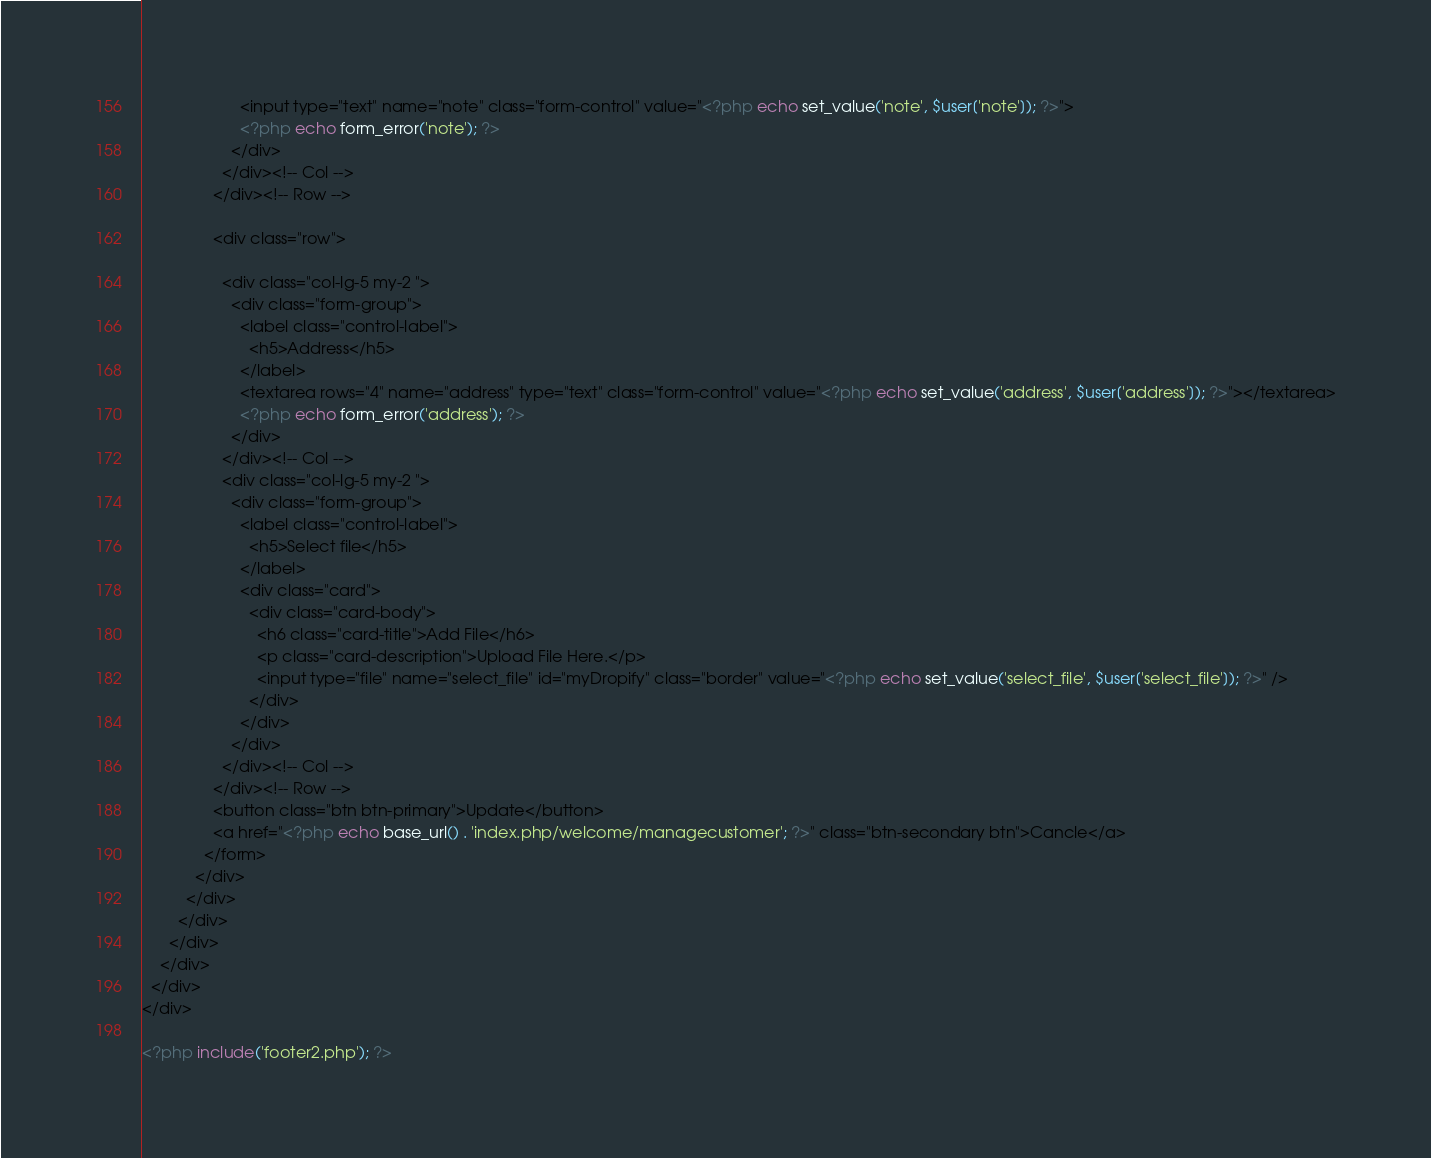<code> <loc_0><loc_0><loc_500><loc_500><_PHP_>                      <input type="text" name="note" class="form-control" value="<?php echo set_value('note', $user['note']); ?>">
                      <?php echo form_error('note'); ?>
                    </div>
                  </div><!-- Col -->
                </div><!-- Row -->

                <div class="row">

                  <div class="col-lg-5 my-2 ">
                    <div class="form-group">
                      <label class="control-label">
                        <h5>Address</h5>
                      </label>
                      <textarea rows="4" name="address" type="text" class="form-control" value="<?php echo set_value('address', $user['address']); ?>"></textarea>
                      <?php echo form_error('address'); ?>
                    </div>
                  </div><!-- Col -->
                  <div class="col-lg-5 my-2 ">
                    <div class="form-group">
                      <label class="control-label">
                        <h5>Select file</h5>
                      </label>
                      <div class="card">
                        <div class="card-body">
                          <h6 class="card-title">Add File</h6>
                          <p class="card-description">Upload File Here.</p>
                          <input type="file" name="select_file" id="myDropify" class="border" value="<?php echo set_value('select_file', $user['select_file']); ?>" />
                        </div>
                      </div>
                    </div>
                  </div><!-- Col -->
                </div><!-- Row -->
                <button class="btn btn-primary">Update</button>
                <a href="<?php echo base_url() . 'index.php/welcome/managecustomer'; ?>" class="btn-secondary btn">Cancle</a>
              </form>
            </div>
          </div>
        </div>
      </div>
    </div>
  </div>
</div>

<?php include('footer2.php'); ?></code> 